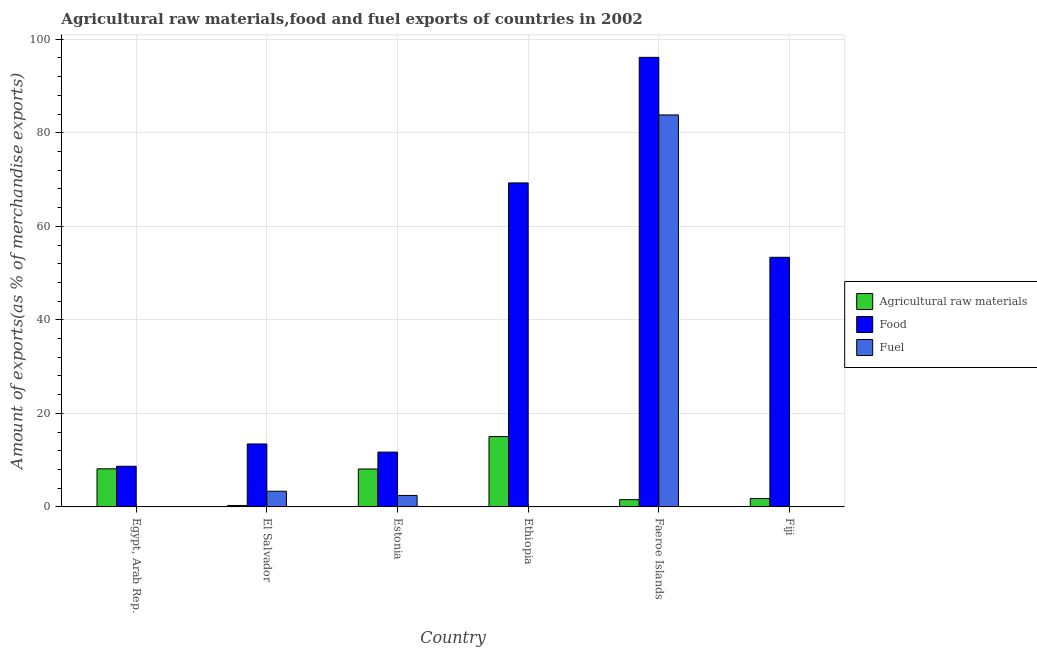How many different coloured bars are there?
Your answer should be compact. 3. How many groups of bars are there?
Your answer should be very brief. 6. Are the number of bars per tick equal to the number of legend labels?
Provide a short and direct response. Yes. What is the label of the 3rd group of bars from the left?
Keep it short and to the point. Estonia. In how many cases, is the number of bars for a given country not equal to the number of legend labels?
Provide a succinct answer. 0. What is the percentage of food exports in El Salvador?
Provide a succinct answer. 13.47. Across all countries, what is the maximum percentage of food exports?
Give a very brief answer. 96.13. Across all countries, what is the minimum percentage of food exports?
Your response must be concise. 8.69. In which country was the percentage of raw materials exports maximum?
Give a very brief answer. Ethiopia. In which country was the percentage of fuel exports minimum?
Offer a very short reply. Egypt, Arab Rep. What is the total percentage of food exports in the graph?
Provide a short and direct response. 252.67. What is the difference between the percentage of fuel exports in El Salvador and that in Estonia?
Your response must be concise. 0.9. What is the difference between the percentage of raw materials exports in Fiji and the percentage of food exports in Egypt, Arab Rep.?
Your answer should be very brief. -6.9. What is the average percentage of raw materials exports per country?
Give a very brief answer. 5.83. What is the difference between the percentage of raw materials exports and percentage of food exports in Egypt, Arab Rep.?
Provide a short and direct response. -0.54. What is the ratio of the percentage of food exports in Ethiopia to that in Fiji?
Keep it short and to the point. 1.3. Is the percentage of raw materials exports in Egypt, Arab Rep. less than that in Estonia?
Keep it short and to the point. No. Is the difference between the percentage of food exports in El Salvador and Fiji greater than the difference between the percentage of raw materials exports in El Salvador and Fiji?
Your answer should be compact. No. What is the difference between the highest and the second highest percentage of raw materials exports?
Your answer should be compact. 6.9. What is the difference between the highest and the lowest percentage of food exports?
Provide a succinct answer. 87.44. In how many countries, is the percentage of raw materials exports greater than the average percentage of raw materials exports taken over all countries?
Your answer should be very brief. 3. Is the sum of the percentage of fuel exports in Ethiopia and Faeroe Islands greater than the maximum percentage of food exports across all countries?
Provide a short and direct response. No. What does the 2nd bar from the left in Ethiopia represents?
Offer a very short reply. Food. What does the 2nd bar from the right in El Salvador represents?
Offer a terse response. Food. Is it the case that in every country, the sum of the percentage of raw materials exports and percentage of food exports is greater than the percentage of fuel exports?
Give a very brief answer. Yes. Are all the bars in the graph horizontal?
Provide a succinct answer. No. What is the difference between two consecutive major ticks on the Y-axis?
Your response must be concise. 20. Does the graph contain any zero values?
Your answer should be compact. No. Does the graph contain grids?
Your response must be concise. Yes. How many legend labels are there?
Provide a succinct answer. 3. How are the legend labels stacked?
Ensure brevity in your answer.  Vertical. What is the title of the graph?
Provide a succinct answer. Agricultural raw materials,food and fuel exports of countries in 2002. What is the label or title of the X-axis?
Make the answer very short. Country. What is the label or title of the Y-axis?
Offer a terse response. Amount of exports(as % of merchandise exports). What is the Amount of exports(as % of merchandise exports) of Agricultural raw materials in Egypt, Arab Rep.?
Your answer should be very brief. 8.15. What is the Amount of exports(as % of merchandise exports) of Food in Egypt, Arab Rep.?
Ensure brevity in your answer.  8.69. What is the Amount of exports(as % of merchandise exports) of Fuel in Egypt, Arab Rep.?
Ensure brevity in your answer.  0. What is the Amount of exports(as % of merchandise exports) of Agricultural raw materials in El Salvador?
Keep it short and to the point. 0.31. What is the Amount of exports(as % of merchandise exports) in Food in El Salvador?
Offer a terse response. 13.47. What is the Amount of exports(as % of merchandise exports) in Fuel in El Salvador?
Your answer should be compact. 3.36. What is the Amount of exports(as % of merchandise exports) of Agricultural raw materials in Estonia?
Offer a very short reply. 8.11. What is the Amount of exports(as % of merchandise exports) in Food in Estonia?
Your answer should be very brief. 11.72. What is the Amount of exports(as % of merchandise exports) in Fuel in Estonia?
Provide a short and direct response. 2.46. What is the Amount of exports(as % of merchandise exports) in Agricultural raw materials in Ethiopia?
Your answer should be very brief. 15.04. What is the Amount of exports(as % of merchandise exports) in Food in Ethiopia?
Keep it short and to the point. 69.28. What is the Amount of exports(as % of merchandise exports) of Fuel in Ethiopia?
Keep it short and to the point. 0.01. What is the Amount of exports(as % of merchandise exports) of Agricultural raw materials in Faeroe Islands?
Give a very brief answer. 1.55. What is the Amount of exports(as % of merchandise exports) of Food in Faeroe Islands?
Your response must be concise. 96.13. What is the Amount of exports(as % of merchandise exports) in Fuel in Faeroe Islands?
Your answer should be very brief. 83.82. What is the Amount of exports(as % of merchandise exports) in Agricultural raw materials in Fiji?
Make the answer very short. 1.79. What is the Amount of exports(as % of merchandise exports) of Food in Fiji?
Make the answer very short. 53.38. What is the Amount of exports(as % of merchandise exports) in Fuel in Fiji?
Offer a very short reply. 0.03. Across all countries, what is the maximum Amount of exports(as % of merchandise exports) of Agricultural raw materials?
Give a very brief answer. 15.04. Across all countries, what is the maximum Amount of exports(as % of merchandise exports) in Food?
Give a very brief answer. 96.13. Across all countries, what is the maximum Amount of exports(as % of merchandise exports) in Fuel?
Ensure brevity in your answer.  83.82. Across all countries, what is the minimum Amount of exports(as % of merchandise exports) in Agricultural raw materials?
Make the answer very short. 0.31. Across all countries, what is the minimum Amount of exports(as % of merchandise exports) in Food?
Your response must be concise. 8.69. Across all countries, what is the minimum Amount of exports(as % of merchandise exports) in Fuel?
Offer a terse response. 0. What is the total Amount of exports(as % of merchandise exports) of Agricultural raw materials in the graph?
Provide a short and direct response. 34.96. What is the total Amount of exports(as % of merchandise exports) in Food in the graph?
Your response must be concise. 252.67. What is the total Amount of exports(as % of merchandise exports) of Fuel in the graph?
Your answer should be compact. 89.67. What is the difference between the Amount of exports(as % of merchandise exports) of Agricultural raw materials in Egypt, Arab Rep. and that in El Salvador?
Provide a succinct answer. 7.84. What is the difference between the Amount of exports(as % of merchandise exports) of Food in Egypt, Arab Rep. and that in El Salvador?
Provide a short and direct response. -4.77. What is the difference between the Amount of exports(as % of merchandise exports) in Fuel in Egypt, Arab Rep. and that in El Salvador?
Provide a succinct answer. -3.36. What is the difference between the Amount of exports(as % of merchandise exports) of Agricultural raw materials in Egypt, Arab Rep. and that in Estonia?
Make the answer very short. 0.04. What is the difference between the Amount of exports(as % of merchandise exports) of Food in Egypt, Arab Rep. and that in Estonia?
Your response must be concise. -3.03. What is the difference between the Amount of exports(as % of merchandise exports) of Fuel in Egypt, Arab Rep. and that in Estonia?
Make the answer very short. -2.45. What is the difference between the Amount of exports(as % of merchandise exports) of Agricultural raw materials in Egypt, Arab Rep. and that in Ethiopia?
Keep it short and to the point. -6.9. What is the difference between the Amount of exports(as % of merchandise exports) of Food in Egypt, Arab Rep. and that in Ethiopia?
Your answer should be compact. -60.59. What is the difference between the Amount of exports(as % of merchandise exports) in Fuel in Egypt, Arab Rep. and that in Ethiopia?
Keep it short and to the point. -0.01. What is the difference between the Amount of exports(as % of merchandise exports) in Agricultural raw materials in Egypt, Arab Rep. and that in Faeroe Islands?
Your answer should be very brief. 6.59. What is the difference between the Amount of exports(as % of merchandise exports) in Food in Egypt, Arab Rep. and that in Faeroe Islands?
Keep it short and to the point. -87.44. What is the difference between the Amount of exports(as % of merchandise exports) of Fuel in Egypt, Arab Rep. and that in Faeroe Islands?
Make the answer very short. -83.82. What is the difference between the Amount of exports(as % of merchandise exports) of Agricultural raw materials in Egypt, Arab Rep. and that in Fiji?
Provide a short and direct response. 6.36. What is the difference between the Amount of exports(as % of merchandise exports) in Food in Egypt, Arab Rep. and that in Fiji?
Provide a succinct answer. -44.69. What is the difference between the Amount of exports(as % of merchandise exports) of Fuel in Egypt, Arab Rep. and that in Fiji?
Ensure brevity in your answer.  -0.03. What is the difference between the Amount of exports(as % of merchandise exports) of Agricultural raw materials in El Salvador and that in Estonia?
Make the answer very short. -7.8. What is the difference between the Amount of exports(as % of merchandise exports) of Food in El Salvador and that in Estonia?
Your response must be concise. 1.75. What is the difference between the Amount of exports(as % of merchandise exports) of Fuel in El Salvador and that in Estonia?
Give a very brief answer. 0.9. What is the difference between the Amount of exports(as % of merchandise exports) in Agricultural raw materials in El Salvador and that in Ethiopia?
Your answer should be compact. -14.73. What is the difference between the Amount of exports(as % of merchandise exports) in Food in El Salvador and that in Ethiopia?
Offer a very short reply. -55.82. What is the difference between the Amount of exports(as % of merchandise exports) of Fuel in El Salvador and that in Ethiopia?
Ensure brevity in your answer.  3.35. What is the difference between the Amount of exports(as % of merchandise exports) of Agricultural raw materials in El Salvador and that in Faeroe Islands?
Ensure brevity in your answer.  -1.24. What is the difference between the Amount of exports(as % of merchandise exports) in Food in El Salvador and that in Faeroe Islands?
Your answer should be very brief. -82.67. What is the difference between the Amount of exports(as % of merchandise exports) in Fuel in El Salvador and that in Faeroe Islands?
Your answer should be compact. -80.46. What is the difference between the Amount of exports(as % of merchandise exports) of Agricultural raw materials in El Salvador and that in Fiji?
Make the answer very short. -1.48. What is the difference between the Amount of exports(as % of merchandise exports) of Food in El Salvador and that in Fiji?
Offer a very short reply. -39.91. What is the difference between the Amount of exports(as % of merchandise exports) in Fuel in El Salvador and that in Fiji?
Keep it short and to the point. 3.33. What is the difference between the Amount of exports(as % of merchandise exports) of Agricultural raw materials in Estonia and that in Ethiopia?
Make the answer very short. -6.93. What is the difference between the Amount of exports(as % of merchandise exports) of Food in Estonia and that in Ethiopia?
Offer a very short reply. -57.56. What is the difference between the Amount of exports(as % of merchandise exports) of Fuel in Estonia and that in Ethiopia?
Offer a very short reply. 2.45. What is the difference between the Amount of exports(as % of merchandise exports) of Agricultural raw materials in Estonia and that in Faeroe Islands?
Give a very brief answer. 6.56. What is the difference between the Amount of exports(as % of merchandise exports) of Food in Estonia and that in Faeroe Islands?
Your answer should be very brief. -84.41. What is the difference between the Amount of exports(as % of merchandise exports) of Fuel in Estonia and that in Faeroe Islands?
Give a very brief answer. -81.36. What is the difference between the Amount of exports(as % of merchandise exports) in Agricultural raw materials in Estonia and that in Fiji?
Your answer should be very brief. 6.32. What is the difference between the Amount of exports(as % of merchandise exports) in Food in Estonia and that in Fiji?
Make the answer very short. -41.66. What is the difference between the Amount of exports(as % of merchandise exports) of Fuel in Estonia and that in Fiji?
Provide a succinct answer. 2.43. What is the difference between the Amount of exports(as % of merchandise exports) in Agricultural raw materials in Ethiopia and that in Faeroe Islands?
Provide a short and direct response. 13.49. What is the difference between the Amount of exports(as % of merchandise exports) of Food in Ethiopia and that in Faeroe Islands?
Ensure brevity in your answer.  -26.85. What is the difference between the Amount of exports(as % of merchandise exports) of Fuel in Ethiopia and that in Faeroe Islands?
Ensure brevity in your answer.  -83.81. What is the difference between the Amount of exports(as % of merchandise exports) of Agricultural raw materials in Ethiopia and that in Fiji?
Your response must be concise. 13.25. What is the difference between the Amount of exports(as % of merchandise exports) in Food in Ethiopia and that in Fiji?
Keep it short and to the point. 15.9. What is the difference between the Amount of exports(as % of merchandise exports) in Fuel in Ethiopia and that in Fiji?
Your answer should be very brief. -0.02. What is the difference between the Amount of exports(as % of merchandise exports) in Agricultural raw materials in Faeroe Islands and that in Fiji?
Give a very brief answer. -0.24. What is the difference between the Amount of exports(as % of merchandise exports) in Food in Faeroe Islands and that in Fiji?
Your answer should be compact. 42.75. What is the difference between the Amount of exports(as % of merchandise exports) of Fuel in Faeroe Islands and that in Fiji?
Provide a succinct answer. 83.79. What is the difference between the Amount of exports(as % of merchandise exports) in Agricultural raw materials in Egypt, Arab Rep. and the Amount of exports(as % of merchandise exports) in Food in El Salvador?
Your response must be concise. -5.32. What is the difference between the Amount of exports(as % of merchandise exports) of Agricultural raw materials in Egypt, Arab Rep. and the Amount of exports(as % of merchandise exports) of Fuel in El Salvador?
Keep it short and to the point. 4.79. What is the difference between the Amount of exports(as % of merchandise exports) of Food in Egypt, Arab Rep. and the Amount of exports(as % of merchandise exports) of Fuel in El Salvador?
Offer a terse response. 5.34. What is the difference between the Amount of exports(as % of merchandise exports) in Agricultural raw materials in Egypt, Arab Rep. and the Amount of exports(as % of merchandise exports) in Food in Estonia?
Offer a very short reply. -3.57. What is the difference between the Amount of exports(as % of merchandise exports) in Agricultural raw materials in Egypt, Arab Rep. and the Amount of exports(as % of merchandise exports) in Fuel in Estonia?
Your answer should be very brief. 5.69. What is the difference between the Amount of exports(as % of merchandise exports) in Food in Egypt, Arab Rep. and the Amount of exports(as % of merchandise exports) in Fuel in Estonia?
Keep it short and to the point. 6.24. What is the difference between the Amount of exports(as % of merchandise exports) of Agricultural raw materials in Egypt, Arab Rep. and the Amount of exports(as % of merchandise exports) of Food in Ethiopia?
Your answer should be very brief. -61.14. What is the difference between the Amount of exports(as % of merchandise exports) of Agricultural raw materials in Egypt, Arab Rep. and the Amount of exports(as % of merchandise exports) of Fuel in Ethiopia?
Your answer should be very brief. 8.14. What is the difference between the Amount of exports(as % of merchandise exports) in Food in Egypt, Arab Rep. and the Amount of exports(as % of merchandise exports) in Fuel in Ethiopia?
Make the answer very short. 8.69. What is the difference between the Amount of exports(as % of merchandise exports) in Agricultural raw materials in Egypt, Arab Rep. and the Amount of exports(as % of merchandise exports) in Food in Faeroe Islands?
Keep it short and to the point. -87.98. What is the difference between the Amount of exports(as % of merchandise exports) in Agricultural raw materials in Egypt, Arab Rep. and the Amount of exports(as % of merchandise exports) in Fuel in Faeroe Islands?
Offer a very short reply. -75.67. What is the difference between the Amount of exports(as % of merchandise exports) in Food in Egypt, Arab Rep. and the Amount of exports(as % of merchandise exports) in Fuel in Faeroe Islands?
Your answer should be very brief. -75.13. What is the difference between the Amount of exports(as % of merchandise exports) in Agricultural raw materials in Egypt, Arab Rep. and the Amount of exports(as % of merchandise exports) in Food in Fiji?
Offer a very short reply. -45.23. What is the difference between the Amount of exports(as % of merchandise exports) in Agricultural raw materials in Egypt, Arab Rep. and the Amount of exports(as % of merchandise exports) in Fuel in Fiji?
Give a very brief answer. 8.12. What is the difference between the Amount of exports(as % of merchandise exports) of Food in Egypt, Arab Rep. and the Amount of exports(as % of merchandise exports) of Fuel in Fiji?
Ensure brevity in your answer.  8.66. What is the difference between the Amount of exports(as % of merchandise exports) of Agricultural raw materials in El Salvador and the Amount of exports(as % of merchandise exports) of Food in Estonia?
Provide a succinct answer. -11.41. What is the difference between the Amount of exports(as % of merchandise exports) of Agricultural raw materials in El Salvador and the Amount of exports(as % of merchandise exports) of Fuel in Estonia?
Make the answer very short. -2.14. What is the difference between the Amount of exports(as % of merchandise exports) of Food in El Salvador and the Amount of exports(as % of merchandise exports) of Fuel in Estonia?
Ensure brevity in your answer.  11.01. What is the difference between the Amount of exports(as % of merchandise exports) in Agricultural raw materials in El Salvador and the Amount of exports(as % of merchandise exports) in Food in Ethiopia?
Your answer should be very brief. -68.97. What is the difference between the Amount of exports(as % of merchandise exports) in Agricultural raw materials in El Salvador and the Amount of exports(as % of merchandise exports) in Fuel in Ethiopia?
Ensure brevity in your answer.  0.31. What is the difference between the Amount of exports(as % of merchandise exports) in Food in El Salvador and the Amount of exports(as % of merchandise exports) in Fuel in Ethiopia?
Offer a terse response. 13.46. What is the difference between the Amount of exports(as % of merchandise exports) in Agricultural raw materials in El Salvador and the Amount of exports(as % of merchandise exports) in Food in Faeroe Islands?
Give a very brief answer. -95.82. What is the difference between the Amount of exports(as % of merchandise exports) of Agricultural raw materials in El Salvador and the Amount of exports(as % of merchandise exports) of Fuel in Faeroe Islands?
Ensure brevity in your answer.  -83.51. What is the difference between the Amount of exports(as % of merchandise exports) in Food in El Salvador and the Amount of exports(as % of merchandise exports) in Fuel in Faeroe Islands?
Ensure brevity in your answer.  -70.35. What is the difference between the Amount of exports(as % of merchandise exports) of Agricultural raw materials in El Salvador and the Amount of exports(as % of merchandise exports) of Food in Fiji?
Your answer should be very brief. -53.07. What is the difference between the Amount of exports(as % of merchandise exports) of Agricultural raw materials in El Salvador and the Amount of exports(as % of merchandise exports) of Fuel in Fiji?
Make the answer very short. 0.28. What is the difference between the Amount of exports(as % of merchandise exports) in Food in El Salvador and the Amount of exports(as % of merchandise exports) in Fuel in Fiji?
Make the answer very short. 13.43. What is the difference between the Amount of exports(as % of merchandise exports) in Agricultural raw materials in Estonia and the Amount of exports(as % of merchandise exports) in Food in Ethiopia?
Ensure brevity in your answer.  -61.17. What is the difference between the Amount of exports(as % of merchandise exports) of Agricultural raw materials in Estonia and the Amount of exports(as % of merchandise exports) of Fuel in Ethiopia?
Your answer should be very brief. 8.1. What is the difference between the Amount of exports(as % of merchandise exports) of Food in Estonia and the Amount of exports(as % of merchandise exports) of Fuel in Ethiopia?
Provide a short and direct response. 11.71. What is the difference between the Amount of exports(as % of merchandise exports) in Agricultural raw materials in Estonia and the Amount of exports(as % of merchandise exports) in Food in Faeroe Islands?
Your answer should be very brief. -88.02. What is the difference between the Amount of exports(as % of merchandise exports) of Agricultural raw materials in Estonia and the Amount of exports(as % of merchandise exports) of Fuel in Faeroe Islands?
Give a very brief answer. -75.71. What is the difference between the Amount of exports(as % of merchandise exports) in Food in Estonia and the Amount of exports(as % of merchandise exports) in Fuel in Faeroe Islands?
Ensure brevity in your answer.  -72.1. What is the difference between the Amount of exports(as % of merchandise exports) of Agricultural raw materials in Estonia and the Amount of exports(as % of merchandise exports) of Food in Fiji?
Make the answer very short. -45.27. What is the difference between the Amount of exports(as % of merchandise exports) in Agricultural raw materials in Estonia and the Amount of exports(as % of merchandise exports) in Fuel in Fiji?
Offer a very short reply. 8.08. What is the difference between the Amount of exports(as % of merchandise exports) in Food in Estonia and the Amount of exports(as % of merchandise exports) in Fuel in Fiji?
Your response must be concise. 11.69. What is the difference between the Amount of exports(as % of merchandise exports) of Agricultural raw materials in Ethiopia and the Amount of exports(as % of merchandise exports) of Food in Faeroe Islands?
Keep it short and to the point. -81.09. What is the difference between the Amount of exports(as % of merchandise exports) of Agricultural raw materials in Ethiopia and the Amount of exports(as % of merchandise exports) of Fuel in Faeroe Islands?
Your answer should be compact. -68.77. What is the difference between the Amount of exports(as % of merchandise exports) in Food in Ethiopia and the Amount of exports(as % of merchandise exports) in Fuel in Faeroe Islands?
Your response must be concise. -14.53. What is the difference between the Amount of exports(as % of merchandise exports) of Agricultural raw materials in Ethiopia and the Amount of exports(as % of merchandise exports) of Food in Fiji?
Offer a terse response. -38.33. What is the difference between the Amount of exports(as % of merchandise exports) of Agricultural raw materials in Ethiopia and the Amount of exports(as % of merchandise exports) of Fuel in Fiji?
Give a very brief answer. 15.01. What is the difference between the Amount of exports(as % of merchandise exports) of Food in Ethiopia and the Amount of exports(as % of merchandise exports) of Fuel in Fiji?
Your answer should be very brief. 69.25. What is the difference between the Amount of exports(as % of merchandise exports) of Agricultural raw materials in Faeroe Islands and the Amount of exports(as % of merchandise exports) of Food in Fiji?
Your answer should be very brief. -51.83. What is the difference between the Amount of exports(as % of merchandise exports) in Agricultural raw materials in Faeroe Islands and the Amount of exports(as % of merchandise exports) in Fuel in Fiji?
Your response must be concise. 1.52. What is the difference between the Amount of exports(as % of merchandise exports) of Food in Faeroe Islands and the Amount of exports(as % of merchandise exports) of Fuel in Fiji?
Give a very brief answer. 96.1. What is the average Amount of exports(as % of merchandise exports) in Agricultural raw materials per country?
Provide a succinct answer. 5.83. What is the average Amount of exports(as % of merchandise exports) in Food per country?
Give a very brief answer. 42.11. What is the average Amount of exports(as % of merchandise exports) of Fuel per country?
Your response must be concise. 14.94. What is the difference between the Amount of exports(as % of merchandise exports) of Agricultural raw materials and Amount of exports(as % of merchandise exports) of Food in Egypt, Arab Rep.?
Provide a succinct answer. -0.54. What is the difference between the Amount of exports(as % of merchandise exports) of Agricultural raw materials and Amount of exports(as % of merchandise exports) of Fuel in Egypt, Arab Rep.?
Ensure brevity in your answer.  8.15. What is the difference between the Amount of exports(as % of merchandise exports) in Food and Amount of exports(as % of merchandise exports) in Fuel in Egypt, Arab Rep.?
Your answer should be very brief. 8.69. What is the difference between the Amount of exports(as % of merchandise exports) in Agricultural raw materials and Amount of exports(as % of merchandise exports) in Food in El Salvador?
Your answer should be very brief. -13.15. What is the difference between the Amount of exports(as % of merchandise exports) of Agricultural raw materials and Amount of exports(as % of merchandise exports) of Fuel in El Salvador?
Your response must be concise. -3.04. What is the difference between the Amount of exports(as % of merchandise exports) of Food and Amount of exports(as % of merchandise exports) of Fuel in El Salvador?
Provide a succinct answer. 10.11. What is the difference between the Amount of exports(as % of merchandise exports) of Agricultural raw materials and Amount of exports(as % of merchandise exports) of Food in Estonia?
Provide a short and direct response. -3.61. What is the difference between the Amount of exports(as % of merchandise exports) in Agricultural raw materials and Amount of exports(as % of merchandise exports) in Fuel in Estonia?
Provide a short and direct response. 5.65. What is the difference between the Amount of exports(as % of merchandise exports) of Food and Amount of exports(as % of merchandise exports) of Fuel in Estonia?
Your answer should be compact. 9.26. What is the difference between the Amount of exports(as % of merchandise exports) in Agricultural raw materials and Amount of exports(as % of merchandise exports) in Food in Ethiopia?
Your answer should be very brief. -54.24. What is the difference between the Amount of exports(as % of merchandise exports) in Agricultural raw materials and Amount of exports(as % of merchandise exports) in Fuel in Ethiopia?
Give a very brief answer. 15.04. What is the difference between the Amount of exports(as % of merchandise exports) in Food and Amount of exports(as % of merchandise exports) in Fuel in Ethiopia?
Offer a terse response. 69.28. What is the difference between the Amount of exports(as % of merchandise exports) of Agricultural raw materials and Amount of exports(as % of merchandise exports) of Food in Faeroe Islands?
Offer a terse response. -94.58. What is the difference between the Amount of exports(as % of merchandise exports) in Agricultural raw materials and Amount of exports(as % of merchandise exports) in Fuel in Faeroe Islands?
Your response must be concise. -82.26. What is the difference between the Amount of exports(as % of merchandise exports) of Food and Amount of exports(as % of merchandise exports) of Fuel in Faeroe Islands?
Your response must be concise. 12.31. What is the difference between the Amount of exports(as % of merchandise exports) in Agricultural raw materials and Amount of exports(as % of merchandise exports) in Food in Fiji?
Your answer should be compact. -51.59. What is the difference between the Amount of exports(as % of merchandise exports) of Agricultural raw materials and Amount of exports(as % of merchandise exports) of Fuel in Fiji?
Make the answer very short. 1.76. What is the difference between the Amount of exports(as % of merchandise exports) of Food and Amount of exports(as % of merchandise exports) of Fuel in Fiji?
Offer a very short reply. 53.35. What is the ratio of the Amount of exports(as % of merchandise exports) in Agricultural raw materials in Egypt, Arab Rep. to that in El Salvador?
Ensure brevity in your answer.  26.11. What is the ratio of the Amount of exports(as % of merchandise exports) of Food in Egypt, Arab Rep. to that in El Salvador?
Keep it short and to the point. 0.65. What is the ratio of the Amount of exports(as % of merchandise exports) in Agricultural raw materials in Egypt, Arab Rep. to that in Estonia?
Your response must be concise. 1. What is the ratio of the Amount of exports(as % of merchandise exports) in Food in Egypt, Arab Rep. to that in Estonia?
Provide a succinct answer. 0.74. What is the ratio of the Amount of exports(as % of merchandise exports) in Fuel in Egypt, Arab Rep. to that in Estonia?
Offer a terse response. 0. What is the ratio of the Amount of exports(as % of merchandise exports) in Agricultural raw materials in Egypt, Arab Rep. to that in Ethiopia?
Your answer should be compact. 0.54. What is the ratio of the Amount of exports(as % of merchandise exports) in Food in Egypt, Arab Rep. to that in Ethiopia?
Your answer should be very brief. 0.13. What is the ratio of the Amount of exports(as % of merchandise exports) in Fuel in Egypt, Arab Rep. to that in Ethiopia?
Keep it short and to the point. 0.11. What is the ratio of the Amount of exports(as % of merchandise exports) in Agricultural raw materials in Egypt, Arab Rep. to that in Faeroe Islands?
Offer a terse response. 5.24. What is the ratio of the Amount of exports(as % of merchandise exports) in Food in Egypt, Arab Rep. to that in Faeroe Islands?
Your answer should be compact. 0.09. What is the ratio of the Amount of exports(as % of merchandise exports) of Fuel in Egypt, Arab Rep. to that in Faeroe Islands?
Keep it short and to the point. 0. What is the ratio of the Amount of exports(as % of merchandise exports) of Agricultural raw materials in Egypt, Arab Rep. to that in Fiji?
Make the answer very short. 4.55. What is the ratio of the Amount of exports(as % of merchandise exports) in Food in Egypt, Arab Rep. to that in Fiji?
Ensure brevity in your answer.  0.16. What is the ratio of the Amount of exports(as % of merchandise exports) of Fuel in Egypt, Arab Rep. to that in Fiji?
Ensure brevity in your answer.  0.02. What is the ratio of the Amount of exports(as % of merchandise exports) of Agricultural raw materials in El Salvador to that in Estonia?
Give a very brief answer. 0.04. What is the ratio of the Amount of exports(as % of merchandise exports) of Food in El Salvador to that in Estonia?
Give a very brief answer. 1.15. What is the ratio of the Amount of exports(as % of merchandise exports) in Fuel in El Salvador to that in Estonia?
Provide a short and direct response. 1.37. What is the ratio of the Amount of exports(as % of merchandise exports) of Agricultural raw materials in El Salvador to that in Ethiopia?
Provide a succinct answer. 0.02. What is the ratio of the Amount of exports(as % of merchandise exports) in Food in El Salvador to that in Ethiopia?
Your answer should be very brief. 0.19. What is the ratio of the Amount of exports(as % of merchandise exports) in Fuel in El Salvador to that in Ethiopia?
Provide a short and direct response. 498.25. What is the ratio of the Amount of exports(as % of merchandise exports) of Agricultural raw materials in El Salvador to that in Faeroe Islands?
Your response must be concise. 0.2. What is the ratio of the Amount of exports(as % of merchandise exports) in Food in El Salvador to that in Faeroe Islands?
Make the answer very short. 0.14. What is the ratio of the Amount of exports(as % of merchandise exports) of Fuel in El Salvador to that in Faeroe Islands?
Offer a terse response. 0.04. What is the ratio of the Amount of exports(as % of merchandise exports) of Agricultural raw materials in El Salvador to that in Fiji?
Offer a terse response. 0.17. What is the ratio of the Amount of exports(as % of merchandise exports) in Food in El Salvador to that in Fiji?
Your answer should be compact. 0.25. What is the ratio of the Amount of exports(as % of merchandise exports) of Fuel in El Salvador to that in Fiji?
Your response must be concise. 110.33. What is the ratio of the Amount of exports(as % of merchandise exports) of Agricultural raw materials in Estonia to that in Ethiopia?
Your answer should be very brief. 0.54. What is the ratio of the Amount of exports(as % of merchandise exports) in Food in Estonia to that in Ethiopia?
Your answer should be compact. 0.17. What is the ratio of the Amount of exports(as % of merchandise exports) of Fuel in Estonia to that in Ethiopia?
Your answer should be compact. 364.52. What is the ratio of the Amount of exports(as % of merchandise exports) of Agricultural raw materials in Estonia to that in Faeroe Islands?
Keep it short and to the point. 5.22. What is the ratio of the Amount of exports(as % of merchandise exports) of Food in Estonia to that in Faeroe Islands?
Your answer should be very brief. 0.12. What is the ratio of the Amount of exports(as % of merchandise exports) of Fuel in Estonia to that in Faeroe Islands?
Offer a terse response. 0.03. What is the ratio of the Amount of exports(as % of merchandise exports) of Agricultural raw materials in Estonia to that in Fiji?
Make the answer very short. 4.52. What is the ratio of the Amount of exports(as % of merchandise exports) in Food in Estonia to that in Fiji?
Offer a very short reply. 0.22. What is the ratio of the Amount of exports(as % of merchandise exports) in Fuel in Estonia to that in Fiji?
Offer a terse response. 80.72. What is the ratio of the Amount of exports(as % of merchandise exports) of Agricultural raw materials in Ethiopia to that in Faeroe Islands?
Make the answer very short. 9.68. What is the ratio of the Amount of exports(as % of merchandise exports) in Food in Ethiopia to that in Faeroe Islands?
Offer a very short reply. 0.72. What is the ratio of the Amount of exports(as % of merchandise exports) in Agricultural raw materials in Ethiopia to that in Fiji?
Provide a succinct answer. 8.39. What is the ratio of the Amount of exports(as % of merchandise exports) in Food in Ethiopia to that in Fiji?
Offer a terse response. 1.3. What is the ratio of the Amount of exports(as % of merchandise exports) of Fuel in Ethiopia to that in Fiji?
Your answer should be very brief. 0.22. What is the ratio of the Amount of exports(as % of merchandise exports) of Agricultural raw materials in Faeroe Islands to that in Fiji?
Your answer should be compact. 0.87. What is the ratio of the Amount of exports(as % of merchandise exports) in Food in Faeroe Islands to that in Fiji?
Your answer should be compact. 1.8. What is the ratio of the Amount of exports(as % of merchandise exports) of Fuel in Faeroe Islands to that in Fiji?
Provide a succinct answer. 2755.2. What is the difference between the highest and the second highest Amount of exports(as % of merchandise exports) of Agricultural raw materials?
Your answer should be very brief. 6.9. What is the difference between the highest and the second highest Amount of exports(as % of merchandise exports) of Food?
Keep it short and to the point. 26.85. What is the difference between the highest and the second highest Amount of exports(as % of merchandise exports) in Fuel?
Provide a succinct answer. 80.46. What is the difference between the highest and the lowest Amount of exports(as % of merchandise exports) in Agricultural raw materials?
Offer a very short reply. 14.73. What is the difference between the highest and the lowest Amount of exports(as % of merchandise exports) in Food?
Ensure brevity in your answer.  87.44. What is the difference between the highest and the lowest Amount of exports(as % of merchandise exports) in Fuel?
Make the answer very short. 83.82. 